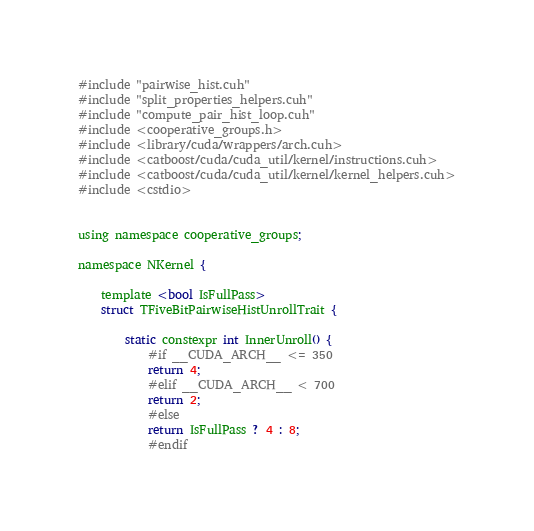<code> <loc_0><loc_0><loc_500><loc_500><_Cuda_>#include "pairwise_hist.cuh"
#include "split_properties_helpers.cuh"
#include "compute_pair_hist_loop.cuh"
#include <cooperative_groups.h>
#include <library/cuda/wrappers/arch.cuh>
#include <catboost/cuda/cuda_util/kernel/instructions.cuh>
#include <catboost/cuda/cuda_util/kernel/kernel_helpers.cuh>
#include <cstdio>


using namespace cooperative_groups;

namespace NKernel {

    template <bool IsFullPass>
    struct TFiveBitPairwiseHistUnrollTrait {

        static constexpr int InnerUnroll() {
            #if __CUDA_ARCH__ <= 350
            return 4;
            #elif __CUDA_ARCH__ < 700
            return 2;
            #else
            return IsFullPass ? 4 : 8;
            #endif</code> 